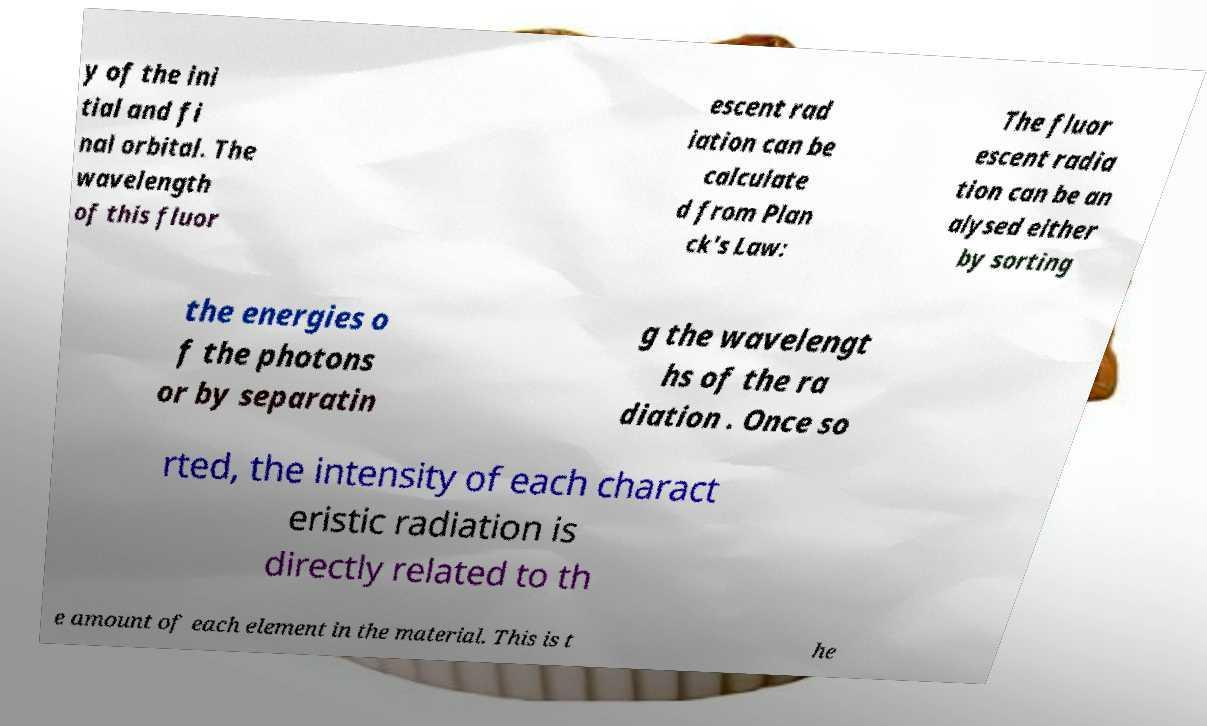Can you accurately transcribe the text from the provided image for me? y of the ini tial and fi nal orbital. The wavelength of this fluor escent rad iation can be calculate d from Plan ck's Law: The fluor escent radia tion can be an alysed either by sorting the energies o f the photons or by separatin g the wavelengt hs of the ra diation . Once so rted, the intensity of each charact eristic radiation is directly related to th e amount of each element in the material. This is t he 